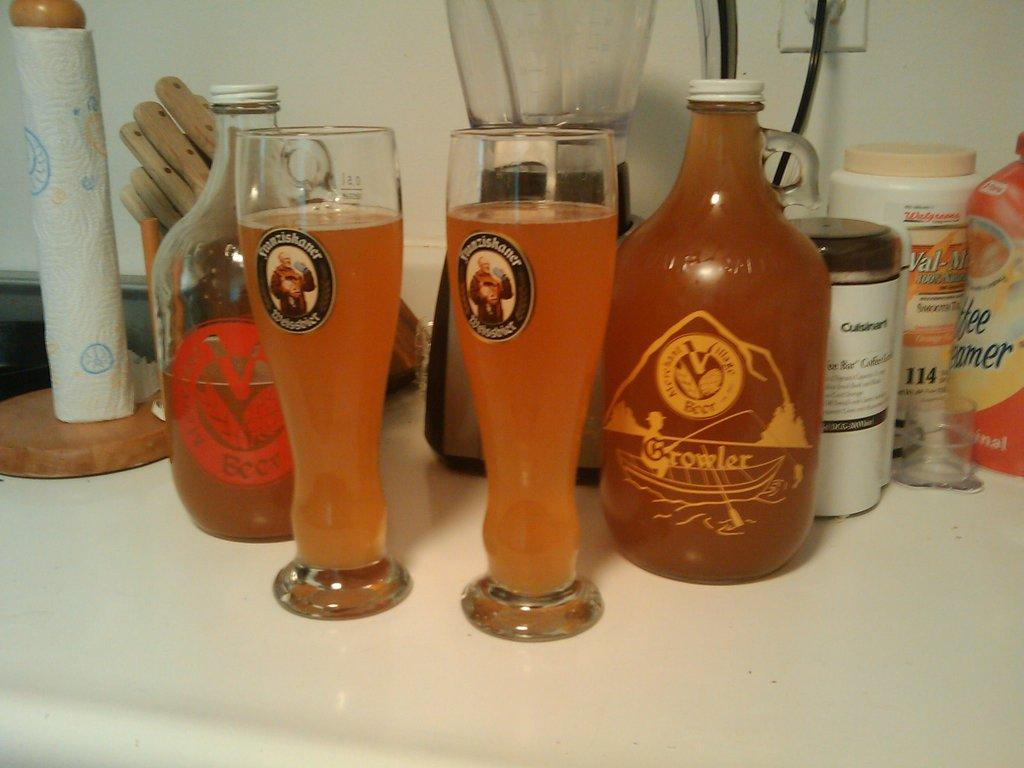<image>
Relay a brief, clear account of the picture shown. Two beer glasses are adorned with the Franziskaner name. 